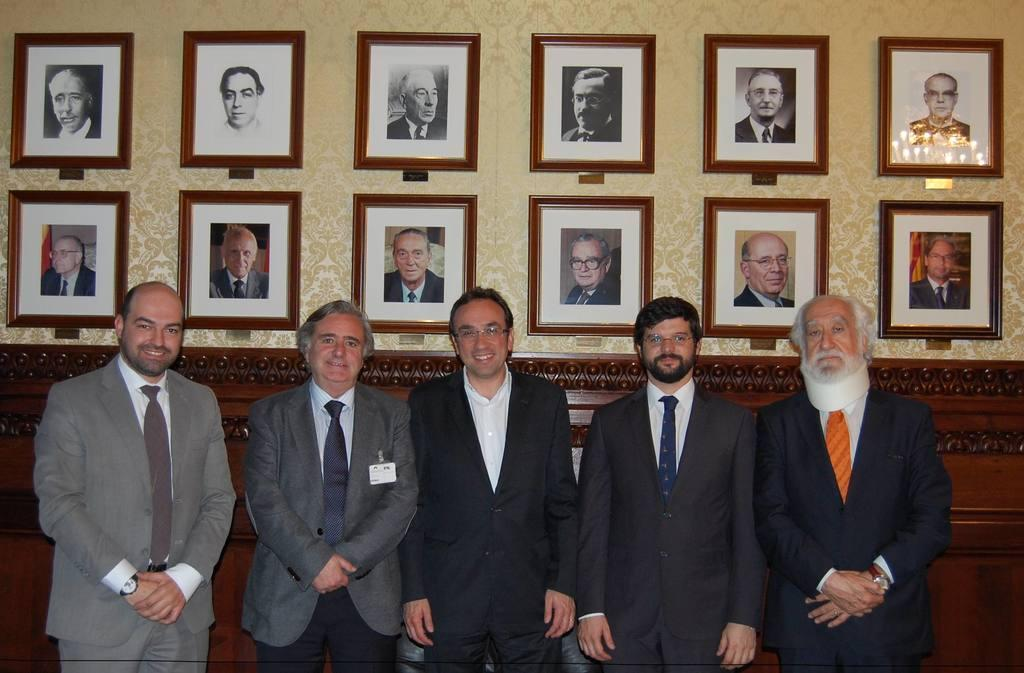How many people are visible in the image? There are a few people in the image. What can be seen on the wall in the image? There are photo frames of people on the wall in the image. What action is the visitor performing in the image? There is no visitor present in the image, so it is not possible to determine what action they might be performing. 